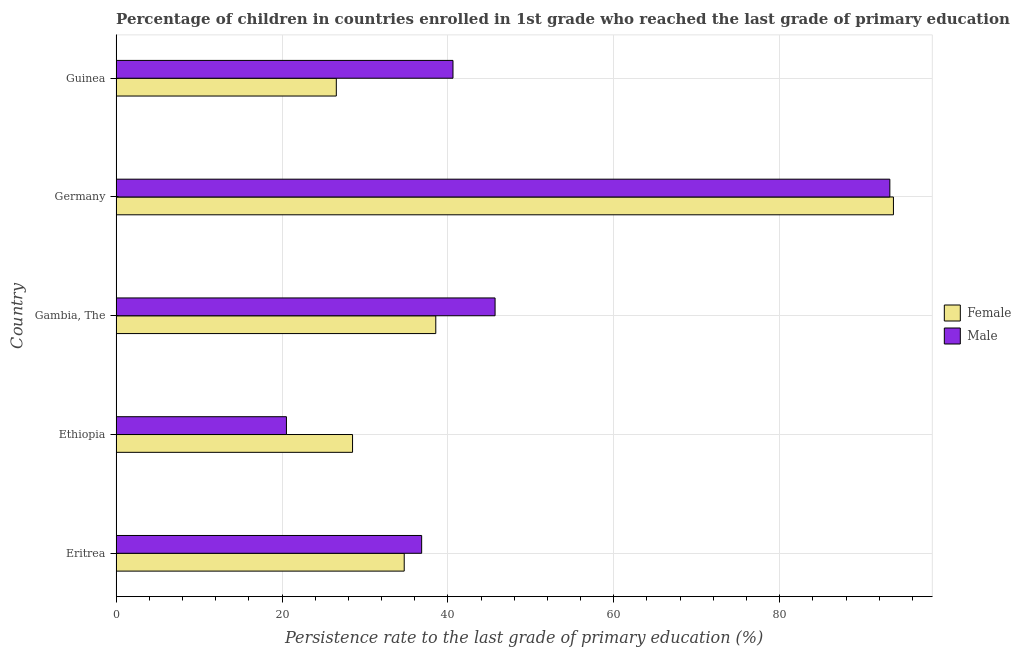How many different coloured bars are there?
Make the answer very short. 2. How many groups of bars are there?
Your answer should be very brief. 5. Are the number of bars per tick equal to the number of legend labels?
Give a very brief answer. Yes. Are the number of bars on each tick of the Y-axis equal?
Offer a very short reply. Yes. How many bars are there on the 3rd tick from the bottom?
Offer a terse response. 2. What is the label of the 4th group of bars from the top?
Ensure brevity in your answer.  Ethiopia. In how many cases, is the number of bars for a given country not equal to the number of legend labels?
Your answer should be compact. 0. What is the persistence rate of female students in Germany?
Ensure brevity in your answer.  93.72. Across all countries, what is the maximum persistence rate of male students?
Offer a terse response. 93.28. Across all countries, what is the minimum persistence rate of female students?
Ensure brevity in your answer.  26.55. In which country was the persistence rate of male students maximum?
Provide a short and direct response. Germany. In which country was the persistence rate of female students minimum?
Keep it short and to the point. Guinea. What is the total persistence rate of female students in the graph?
Give a very brief answer. 222.04. What is the difference between the persistence rate of female students in Eritrea and that in Guinea?
Your answer should be compact. 8.19. What is the difference between the persistence rate of female students in Eritrea and the persistence rate of male students in Guinea?
Make the answer very short. -5.88. What is the average persistence rate of female students per country?
Provide a short and direct response. 44.41. What is the difference between the persistence rate of female students and persistence rate of male students in Guinea?
Give a very brief answer. -14.06. What is the ratio of the persistence rate of female students in Eritrea to that in Gambia, The?
Ensure brevity in your answer.  0.9. Is the persistence rate of female students in Eritrea less than that in Ethiopia?
Your answer should be very brief. No. What is the difference between the highest and the second highest persistence rate of male students?
Offer a terse response. 47.59. What is the difference between the highest and the lowest persistence rate of male students?
Offer a terse response. 72.75. What does the 1st bar from the top in Gambia, The represents?
Provide a short and direct response. Male. What does the 2nd bar from the bottom in Germany represents?
Your answer should be compact. Male. Are all the bars in the graph horizontal?
Make the answer very short. Yes. How many countries are there in the graph?
Keep it short and to the point. 5. What is the difference between two consecutive major ticks on the X-axis?
Provide a short and direct response. 20. What is the title of the graph?
Your answer should be compact. Percentage of children in countries enrolled in 1st grade who reached the last grade of primary education. Does "Food" appear as one of the legend labels in the graph?
Offer a terse response. No. What is the label or title of the X-axis?
Give a very brief answer. Persistence rate to the last grade of primary education (%). What is the label or title of the Y-axis?
Your response must be concise. Country. What is the Persistence rate to the last grade of primary education (%) in Female in Eritrea?
Your answer should be compact. 34.73. What is the Persistence rate to the last grade of primary education (%) of Male in Eritrea?
Provide a short and direct response. 36.84. What is the Persistence rate to the last grade of primary education (%) in Female in Ethiopia?
Your answer should be compact. 28.5. What is the Persistence rate to the last grade of primary education (%) of Male in Ethiopia?
Offer a very short reply. 20.53. What is the Persistence rate to the last grade of primary education (%) in Female in Gambia, The?
Offer a terse response. 38.54. What is the Persistence rate to the last grade of primary education (%) of Male in Gambia, The?
Offer a terse response. 45.69. What is the Persistence rate to the last grade of primary education (%) in Female in Germany?
Provide a succinct answer. 93.72. What is the Persistence rate to the last grade of primary education (%) in Male in Germany?
Your answer should be compact. 93.28. What is the Persistence rate to the last grade of primary education (%) of Female in Guinea?
Provide a succinct answer. 26.55. What is the Persistence rate to the last grade of primary education (%) in Male in Guinea?
Provide a short and direct response. 40.61. Across all countries, what is the maximum Persistence rate to the last grade of primary education (%) in Female?
Make the answer very short. 93.72. Across all countries, what is the maximum Persistence rate to the last grade of primary education (%) in Male?
Keep it short and to the point. 93.28. Across all countries, what is the minimum Persistence rate to the last grade of primary education (%) of Female?
Give a very brief answer. 26.55. Across all countries, what is the minimum Persistence rate to the last grade of primary education (%) of Male?
Your answer should be very brief. 20.53. What is the total Persistence rate to the last grade of primary education (%) of Female in the graph?
Your response must be concise. 222.04. What is the total Persistence rate to the last grade of primary education (%) of Male in the graph?
Your response must be concise. 236.95. What is the difference between the Persistence rate to the last grade of primary education (%) of Female in Eritrea and that in Ethiopia?
Make the answer very short. 6.23. What is the difference between the Persistence rate to the last grade of primary education (%) in Male in Eritrea and that in Ethiopia?
Your answer should be compact. 16.3. What is the difference between the Persistence rate to the last grade of primary education (%) in Female in Eritrea and that in Gambia, The?
Your answer should be very brief. -3.81. What is the difference between the Persistence rate to the last grade of primary education (%) of Male in Eritrea and that in Gambia, The?
Give a very brief answer. -8.85. What is the difference between the Persistence rate to the last grade of primary education (%) of Female in Eritrea and that in Germany?
Provide a short and direct response. -58.98. What is the difference between the Persistence rate to the last grade of primary education (%) of Male in Eritrea and that in Germany?
Ensure brevity in your answer.  -56.45. What is the difference between the Persistence rate to the last grade of primary education (%) of Female in Eritrea and that in Guinea?
Offer a very short reply. 8.19. What is the difference between the Persistence rate to the last grade of primary education (%) in Male in Eritrea and that in Guinea?
Give a very brief answer. -3.78. What is the difference between the Persistence rate to the last grade of primary education (%) in Female in Ethiopia and that in Gambia, The?
Your answer should be compact. -10.03. What is the difference between the Persistence rate to the last grade of primary education (%) of Male in Ethiopia and that in Gambia, The?
Ensure brevity in your answer.  -25.15. What is the difference between the Persistence rate to the last grade of primary education (%) in Female in Ethiopia and that in Germany?
Make the answer very short. -65.21. What is the difference between the Persistence rate to the last grade of primary education (%) in Male in Ethiopia and that in Germany?
Make the answer very short. -72.75. What is the difference between the Persistence rate to the last grade of primary education (%) in Female in Ethiopia and that in Guinea?
Give a very brief answer. 1.96. What is the difference between the Persistence rate to the last grade of primary education (%) in Male in Ethiopia and that in Guinea?
Your response must be concise. -20.08. What is the difference between the Persistence rate to the last grade of primary education (%) of Female in Gambia, The and that in Germany?
Offer a terse response. -55.18. What is the difference between the Persistence rate to the last grade of primary education (%) in Male in Gambia, The and that in Germany?
Your response must be concise. -47.59. What is the difference between the Persistence rate to the last grade of primary education (%) in Female in Gambia, The and that in Guinea?
Your answer should be very brief. 11.99. What is the difference between the Persistence rate to the last grade of primary education (%) of Male in Gambia, The and that in Guinea?
Your response must be concise. 5.08. What is the difference between the Persistence rate to the last grade of primary education (%) in Female in Germany and that in Guinea?
Your answer should be compact. 67.17. What is the difference between the Persistence rate to the last grade of primary education (%) in Male in Germany and that in Guinea?
Your answer should be compact. 52.67. What is the difference between the Persistence rate to the last grade of primary education (%) of Female in Eritrea and the Persistence rate to the last grade of primary education (%) of Male in Ethiopia?
Provide a succinct answer. 14.2. What is the difference between the Persistence rate to the last grade of primary education (%) in Female in Eritrea and the Persistence rate to the last grade of primary education (%) in Male in Gambia, The?
Keep it short and to the point. -10.96. What is the difference between the Persistence rate to the last grade of primary education (%) in Female in Eritrea and the Persistence rate to the last grade of primary education (%) in Male in Germany?
Make the answer very short. -58.55. What is the difference between the Persistence rate to the last grade of primary education (%) of Female in Eritrea and the Persistence rate to the last grade of primary education (%) of Male in Guinea?
Keep it short and to the point. -5.88. What is the difference between the Persistence rate to the last grade of primary education (%) in Female in Ethiopia and the Persistence rate to the last grade of primary education (%) in Male in Gambia, The?
Give a very brief answer. -17.18. What is the difference between the Persistence rate to the last grade of primary education (%) in Female in Ethiopia and the Persistence rate to the last grade of primary education (%) in Male in Germany?
Make the answer very short. -64.78. What is the difference between the Persistence rate to the last grade of primary education (%) in Female in Ethiopia and the Persistence rate to the last grade of primary education (%) in Male in Guinea?
Keep it short and to the point. -12.11. What is the difference between the Persistence rate to the last grade of primary education (%) of Female in Gambia, The and the Persistence rate to the last grade of primary education (%) of Male in Germany?
Ensure brevity in your answer.  -54.74. What is the difference between the Persistence rate to the last grade of primary education (%) of Female in Gambia, The and the Persistence rate to the last grade of primary education (%) of Male in Guinea?
Your answer should be very brief. -2.07. What is the difference between the Persistence rate to the last grade of primary education (%) of Female in Germany and the Persistence rate to the last grade of primary education (%) of Male in Guinea?
Your answer should be compact. 53.1. What is the average Persistence rate to the last grade of primary education (%) in Female per country?
Provide a short and direct response. 44.41. What is the average Persistence rate to the last grade of primary education (%) in Male per country?
Offer a terse response. 47.39. What is the difference between the Persistence rate to the last grade of primary education (%) of Female and Persistence rate to the last grade of primary education (%) of Male in Eritrea?
Ensure brevity in your answer.  -2.1. What is the difference between the Persistence rate to the last grade of primary education (%) in Female and Persistence rate to the last grade of primary education (%) in Male in Ethiopia?
Offer a terse response. 7.97. What is the difference between the Persistence rate to the last grade of primary education (%) of Female and Persistence rate to the last grade of primary education (%) of Male in Gambia, The?
Ensure brevity in your answer.  -7.15. What is the difference between the Persistence rate to the last grade of primary education (%) in Female and Persistence rate to the last grade of primary education (%) in Male in Germany?
Your response must be concise. 0.43. What is the difference between the Persistence rate to the last grade of primary education (%) in Female and Persistence rate to the last grade of primary education (%) in Male in Guinea?
Provide a succinct answer. -14.06. What is the ratio of the Persistence rate to the last grade of primary education (%) in Female in Eritrea to that in Ethiopia?
Offer a very short reply. 1.22. What is the ratio of the Persistence rate to the last grade of primary education (%) of Male in Eritrea to that in Ethiopia?
Make the answer very short. 1.79. What is the ratio of the Persistence rate to the last grade of primary education (%) in Female in Eritrea to that in Gambia, The?
Offer a very short reply. 0.9. What is the ratio of the Persistence rate to the last grade of primary education (%) in Male in Eritrea to that in Gambia, The?
Offer a very short reply. 0.81. What is the ratio of the Persistence rate to the last grade of primary education (%) in Female in Eritrea to that in Germany?
Offer a very short reply. 0.37. What is the ratio of the Persistence rate to the last grade of primary education (%) in Male in Eritrea to that in Germany?
Offer a terse response. 0.39. What is the ratio of the Persistence rate to the last grade of primary education (%) of Female in Eritrea to that in Guinea?
Provide a succinct answer. 1.31. What is the ratio of the Persistence rate to the last grade of primary education (%) in Male in Eritrea to that in Guinea?
Give a very brief answer. 0.91. What is the ratio of the Persistence rate to the last grade of primary education (%) in Female in Ethiopia to that in Gambia, The?
Your answer should be compact. 0.74. What is the ratio of the Persistence rate to the last grade of primary education (%) in Male in Ethiopia to that in Gambia, The?
Keep it short and to the point. 0.45. What is the ratio of the Persistence rate to the last grade of primary education (%) in Female in Ethiopia to that in Germany?
Your answer should be very brief. 0.3. What is the ratio of the Persistence rate to the last grade of primary education (%) in Male in Ethiopia to that in Germany?
Offer a terse response. 0.22. What is the ratio of the Persistence rate to the last grade of primary education (%) of Female in Ethiopia to that in Guinea?
Provide a succinct answer. 1.07. What is the ratio of the Persistence rate to the last grade of primary education (%) in Male in Ethiopia to that in Guinea?
Your answer should be compact. 0.51. What is the ratio of the Persistence rate to the last grade of primary education (%) in Female in Gambia, The to that in Germany?
Ensure brevity in your answer.  0.41. What is the ratio of the Persistence rate to the last grade of primary education (%) of Male in Gambia, The to that in Germany?
Your response must be concise. 0.49. What is the ratio of the Persistence rate to the last grade of primary education (%) of Female in Gambia, The to that in Guinea?
Your answer should be very brief. 1.45. What is the ratio of the Persistence rate to the last grade of primary education (%) of Female in Germany to that in Guinea?
Offer a terse response. 3.53. What is the ratio of the Persistence rate to the last grade of primary education (%) of Male in Germany to that in Guinea?
Make the answer very short. 2.3. What is the difference between the highest and the second highest Persistence rate to the last grade of primary education (%) in Female?
Ensure brevity in your answer.  55.18. What is the difference between the highest and the second highest Persistence rate to the last grade of primary education (%) of Male?
Your response must be concise. 47.59. What is the difference between the highest and the lowest Persistence rate to the last grade of primary education (%) in Female?
Provide a succinct answer. 67.17. What is the difference between the highest and the lowest Persistence rate to the last grade of primary education (%) in Male?
Make the answer very short. 72.75. 